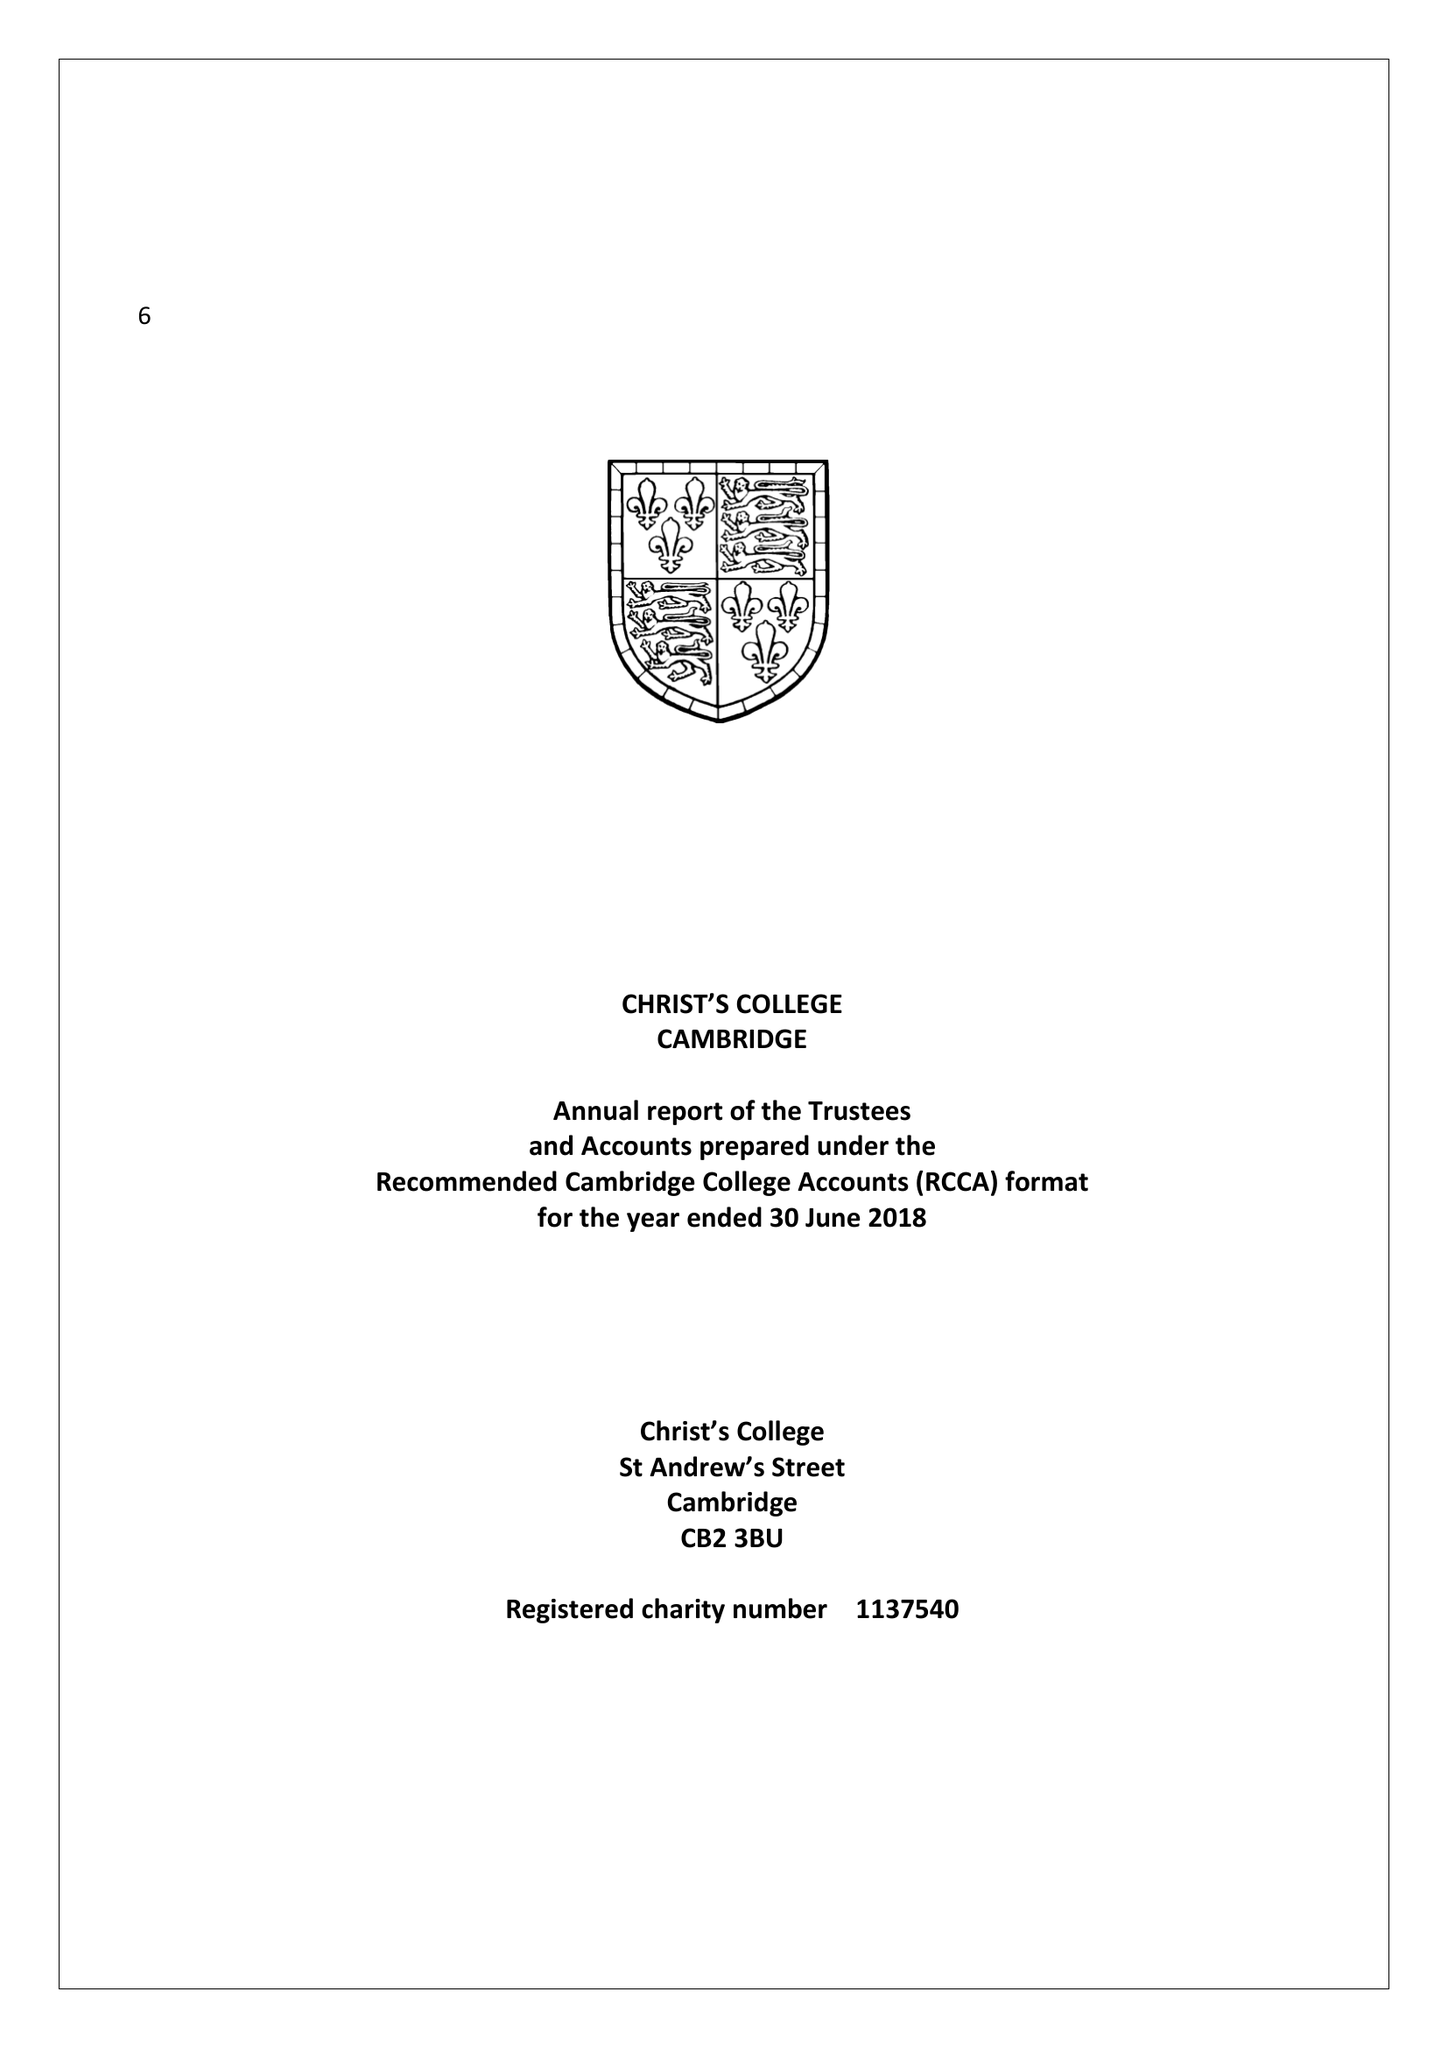What is the value for the address__postcode?
Answer the question using a single word or phrase. CB2 3BU 